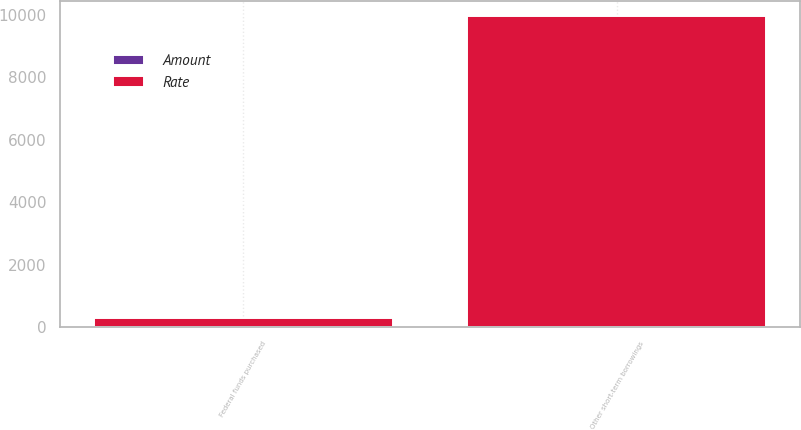Convert chart. <chart><loc_0><loc_0><loc_500><loc_500><stacked_bar_chart><ecel><fcel>Federal funds purchased<fcel>Other short-term borrowings<nl><fcel>Rate<fcel>287<fcel>9959<nl><fcel>Amount<fcel>0.18<fcel>1.42<nl></chart> 